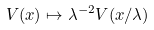Convert formula to latex. <formula><loc_0><loc_0><loc_500><loc_500>V ( x ) \mapsto \lambda ^ { - 2 } V ( x / \lambda )</formula> 